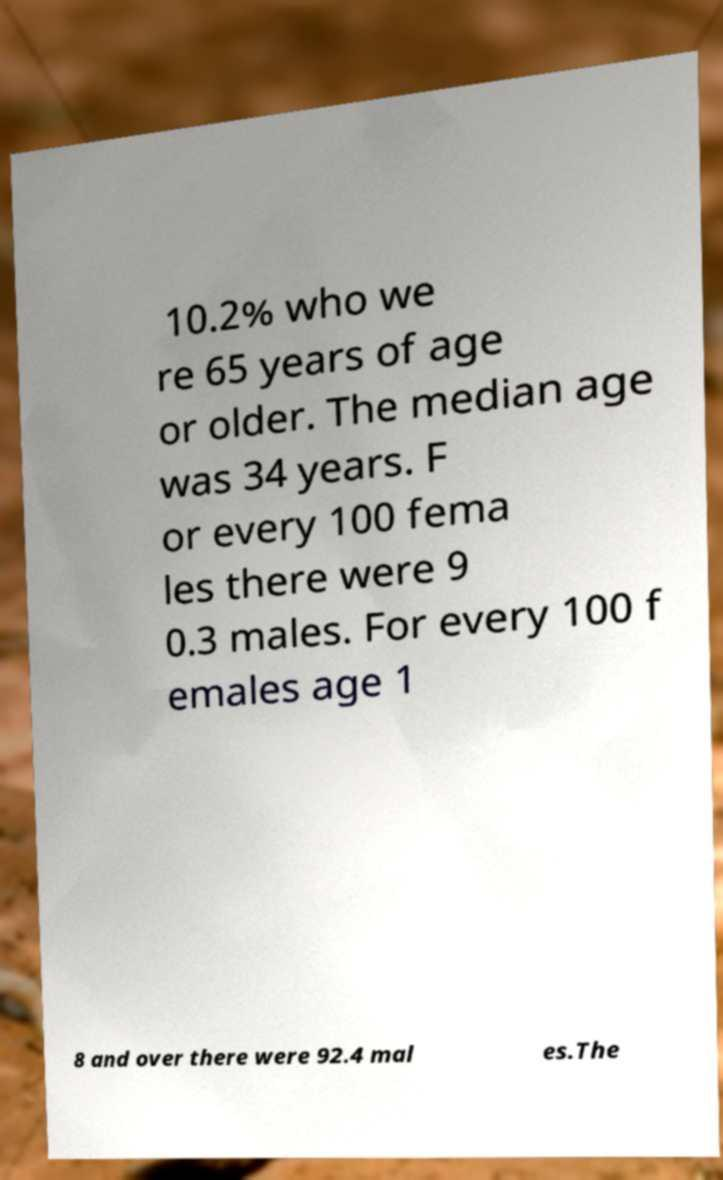Please read and relay the text visible in this image. What does it say? 10.2% who we re 65 years of age or older. The median age was 34 years. F or every 100 fema les there were 9 0.3 males. For every 100 f emales age 1 8 and over there were 92.4 mal es.The 